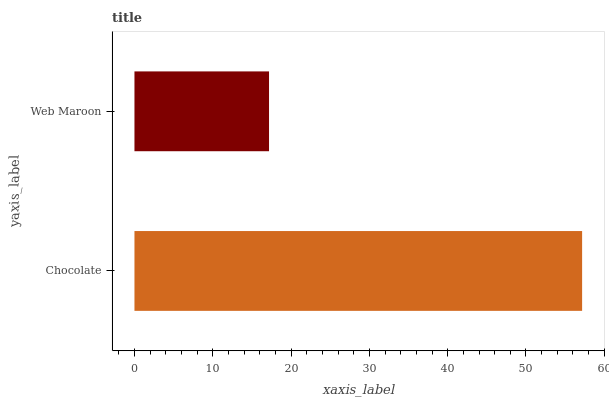Is Web Maroon the minimum?
Answer yes or no. Yes. Is Chocolate the maximum?
Answer yes or no. Yes. Is Web Maroon the maximum?
Answer yes or no. No. Is Chocolate greater than Web Maroon?
Answer yes or no. Yes. Is Web Maroon less than Chocolate?
Answer yes or no. Yes. Is Web Maroon greater than Chocolate?
Answer yes or no. No. Is Chocolate less than Web Maroon?
Answer yes or no. No. Is Chocolate the high median?
Answer yes or no. Yes. Is Web Maroon the low median?
Answer yes or no. Yes. Is Web Maroon the high median?
Answer yes or no. No. Is Chocolate the low median?
Answer yes or no. No. 